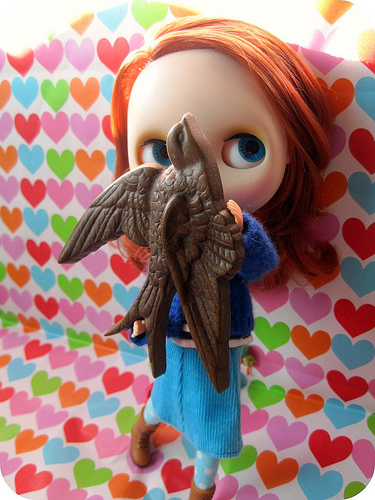<image>
Can you confirm if the wall is behind the doll? Yes. From this viewpoint, the wall is positioned behind the doll, with the doll partially or fully occluding the wall. Is the doll in front of the bird? No. The doll is not in front of the bird. The spatial positioning shows a different relationship between these objects. 